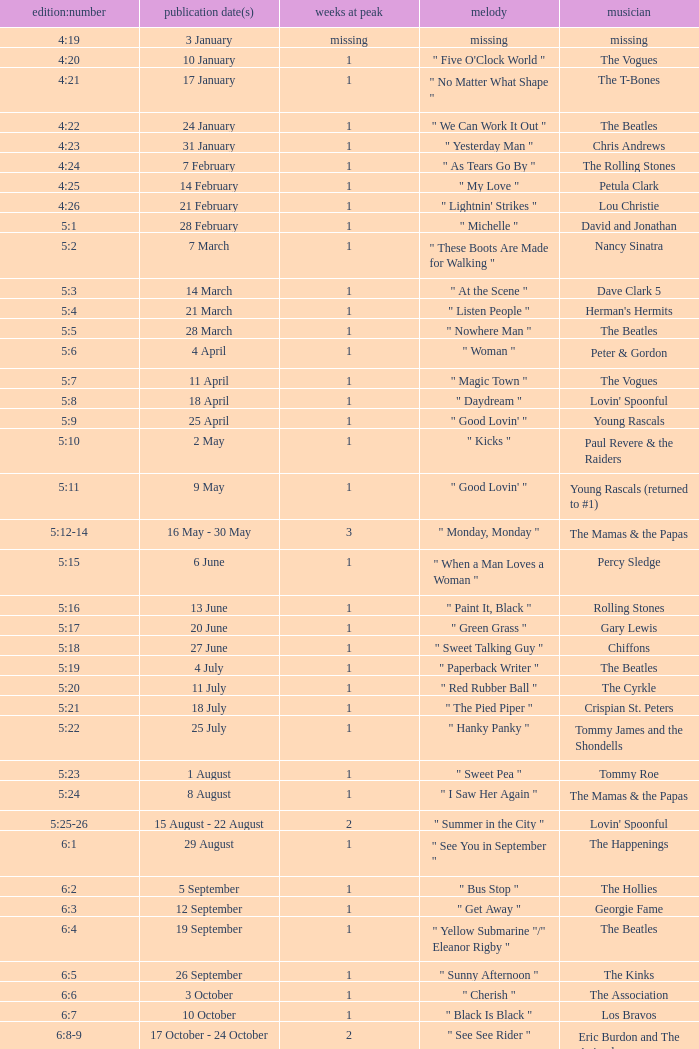Volume:Issue of 5:16 has what song listed? " Paint It, Black ". 